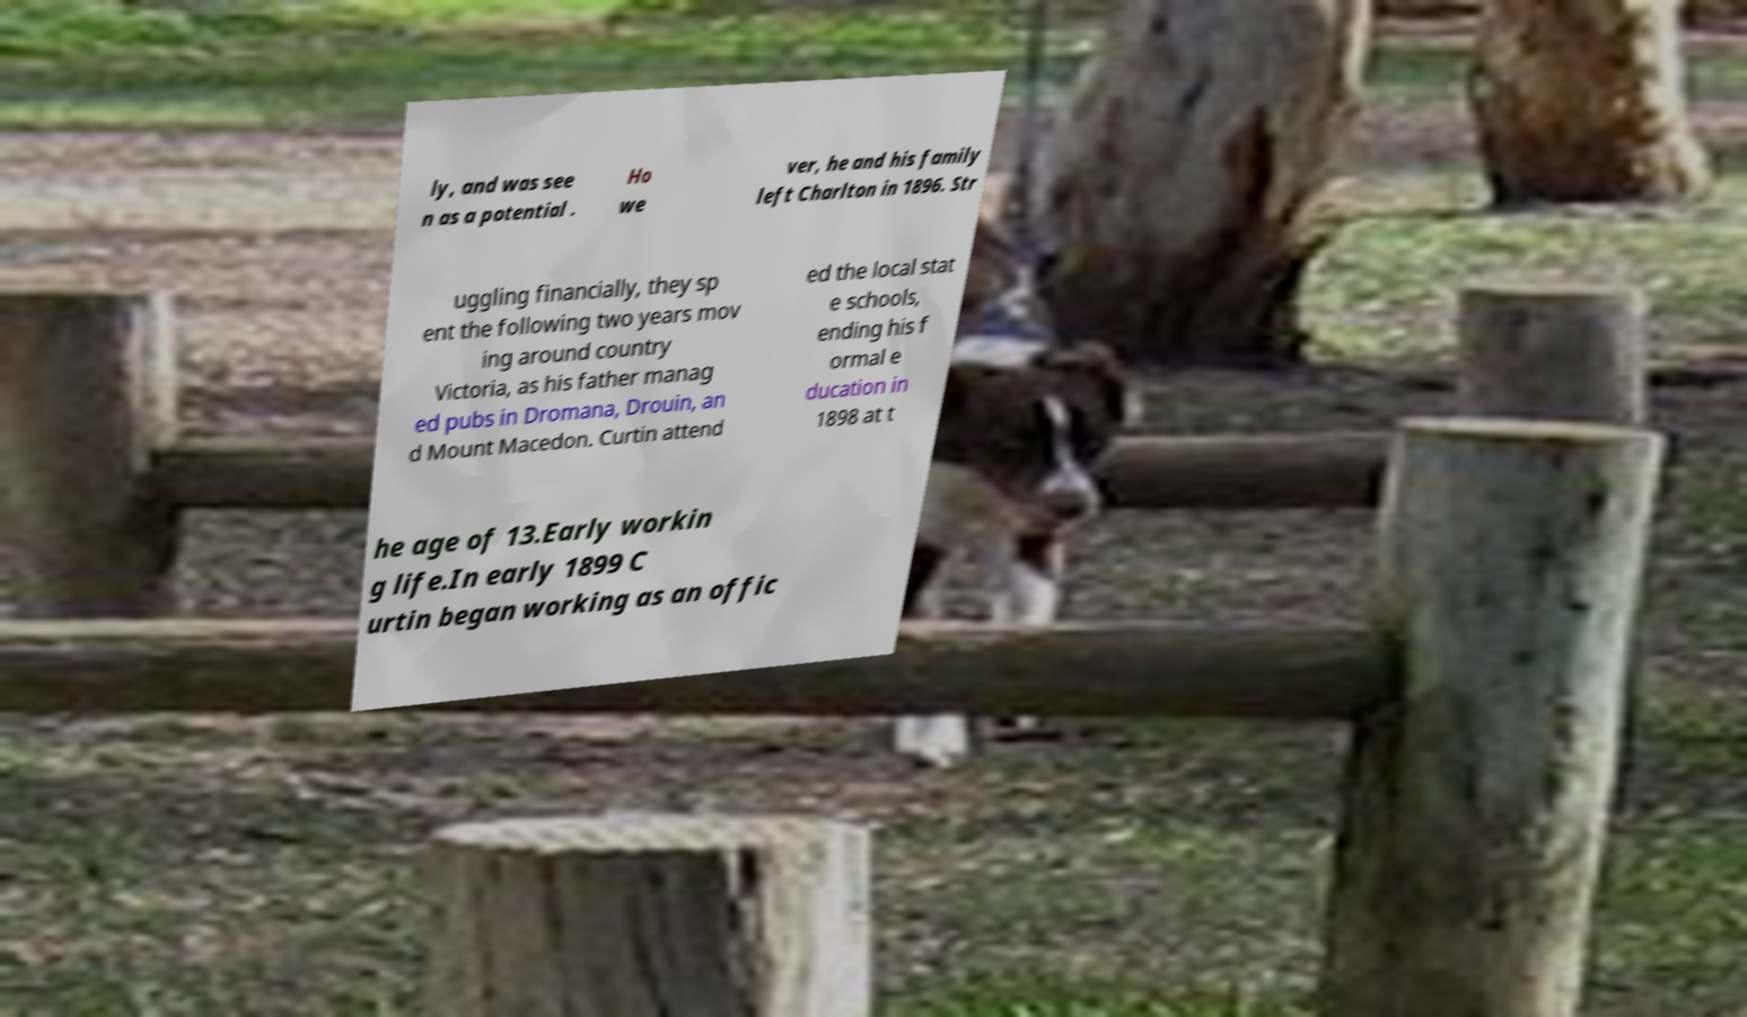I need the written content from this picture converted into text. Can you do that? ly, and was see n as a potential . Ho we ver, he and his family left Charlton in 1896. Str uggling financially, they sp ent the following two years mov ing around country Victoria, as his father manag ed pubs in Dromana, Drouin, an d Mount Macedon. Curtin attend ed the local stat e schools, ending his f ormal e ducation in 1898 at t he age of 13.Early workin g life.In early 1899 C urtin began working as an offic 